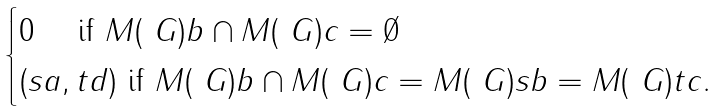<formula> <loc_0><loc_0><loc_500><loc_500>\begin{cases} 0 \quad \text { if } M ( \ G ) b \cap M ( \ G ) c = \emptyset \\ ( s a , t d ) \text { if } M ( \ G ) b \cap M ( \ G ) c = M ( \ G ) s b = M ( \ G ) t c . \end{cases}</formula> 